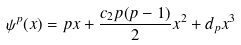Convert formula to latex. <formula><loc_0><loc_0><loc_500><loc_500>\psi ^ { p } ( x ) = p x + \frac { c _ { 2 } p ( p - 1 ) } { 2 } x ^ { 2 } + d _ { p } x ^ { 3 }</formula> 